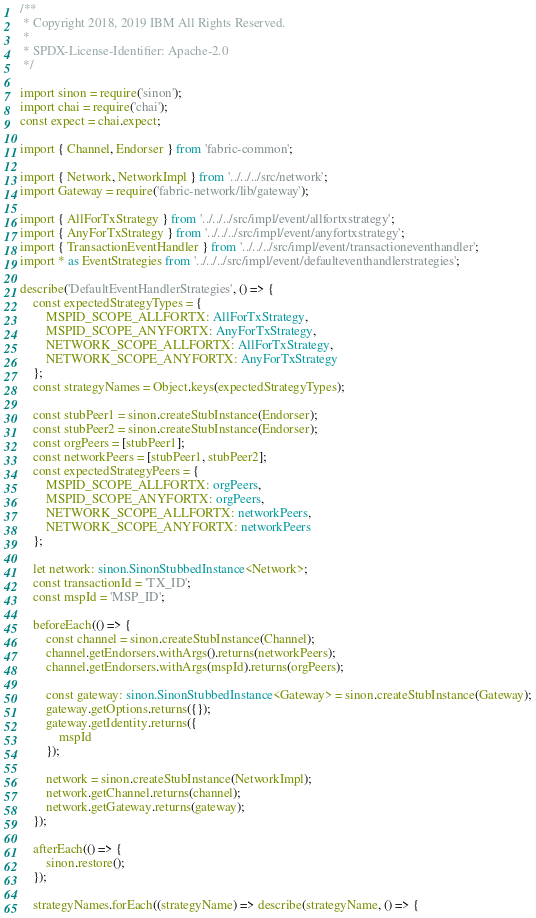Convert code to text. <code><loc_0><loc_0><loc_500><loc_500><_TypeScript_>/**
 * Copyright 2018, 2019 IBM All Rights Reserved.
 *
 * SPDX-License-Identifier: Apache-2.0
 */

import sinon = require('sinon');
import chai = require('chai');
const expect = chai.expect;

import { Channel, Endorser } from 'fabric-common';

import { Network, NetworkImpl } from '../../../src/network';
import Gateway = require('fabric-network/lib/gateway');

import { AllForTxStrategy } from '../../../src/impl/event/allfortxstrategy';
import { AnyForTxStrategy } from '../../../src/impl/event/anyfortxstrategy';
import { TransactionEventHandler } from '../../../src/impl/event/transactioneventhandler';
import * as EventStrategies from '../../../src/impl/event/defaulteventhandlerstrategies';

describe('DefaultEventHandlerStrategies', () => {
	const expectedStrategyTypes = {
		MSPID_SCOPE_ALLFORTX: AllForTxStrategy,
		MSPID_SCOPE_ANYFORTX: AnyForTxStrategy,
		NETWORK_SCOPE_ALLFORTX: AllForTxStrategy,
		NETWORK_SCOPE_ANYFORTX: AnyForTxStrategy
	};
	const strategyNames = Object.keys(expectedStrategyTypes);

	const stubPeer1 = sinon.createStubInstance(Endorser);
	const stubPeer2 = sinon.createStubInstance(Endorser);
	const orgPeers = [stubPeer1];
	const networkPeers = [stubPeer1, stubPeer2];
	const expectedStrategyPeers = {
		MSPID_SCOPE_ALLFORTX: orgPeers,
		MSPID_SCOPE_ANYFORTX: orgPeers,
		NETWORK_SCOPE_ALLFORTX: networkPeers,
		NETWORK_SCOPE_ANYFORTX: networkPeers
	};

	let network: sinon.SinonStubbedInstance<Network>;
	const transactionId = 'TX_ID';
	const mspId = 'MSP_ID';

	beforeEach(() => {
		const channel = sinon.createStubInstance(Channel);
		channel.getEndorsers.withArgs().returns(networkPeers);
		channel.getEndorsers.withArgs(mspId).returns(orgPeers);

		const gateway: sinon.SinonStubbedInstance<Gateway> = sinon.createStubInstance(Gateway);
		gateway.getOptions.returns({});
		gateway.getIdentity.returns({
			mspId
		});

		network = sinon.createStubInstance(NetworkImpl);
		network.getChannel.returns(channel);
		network.getGateway.returns(gateway);
	});

	afterEach(() => {
		sinon.restore();
	});

	strategyNames.forEach((strategyName) => describe(strategyName, () => {</code> 